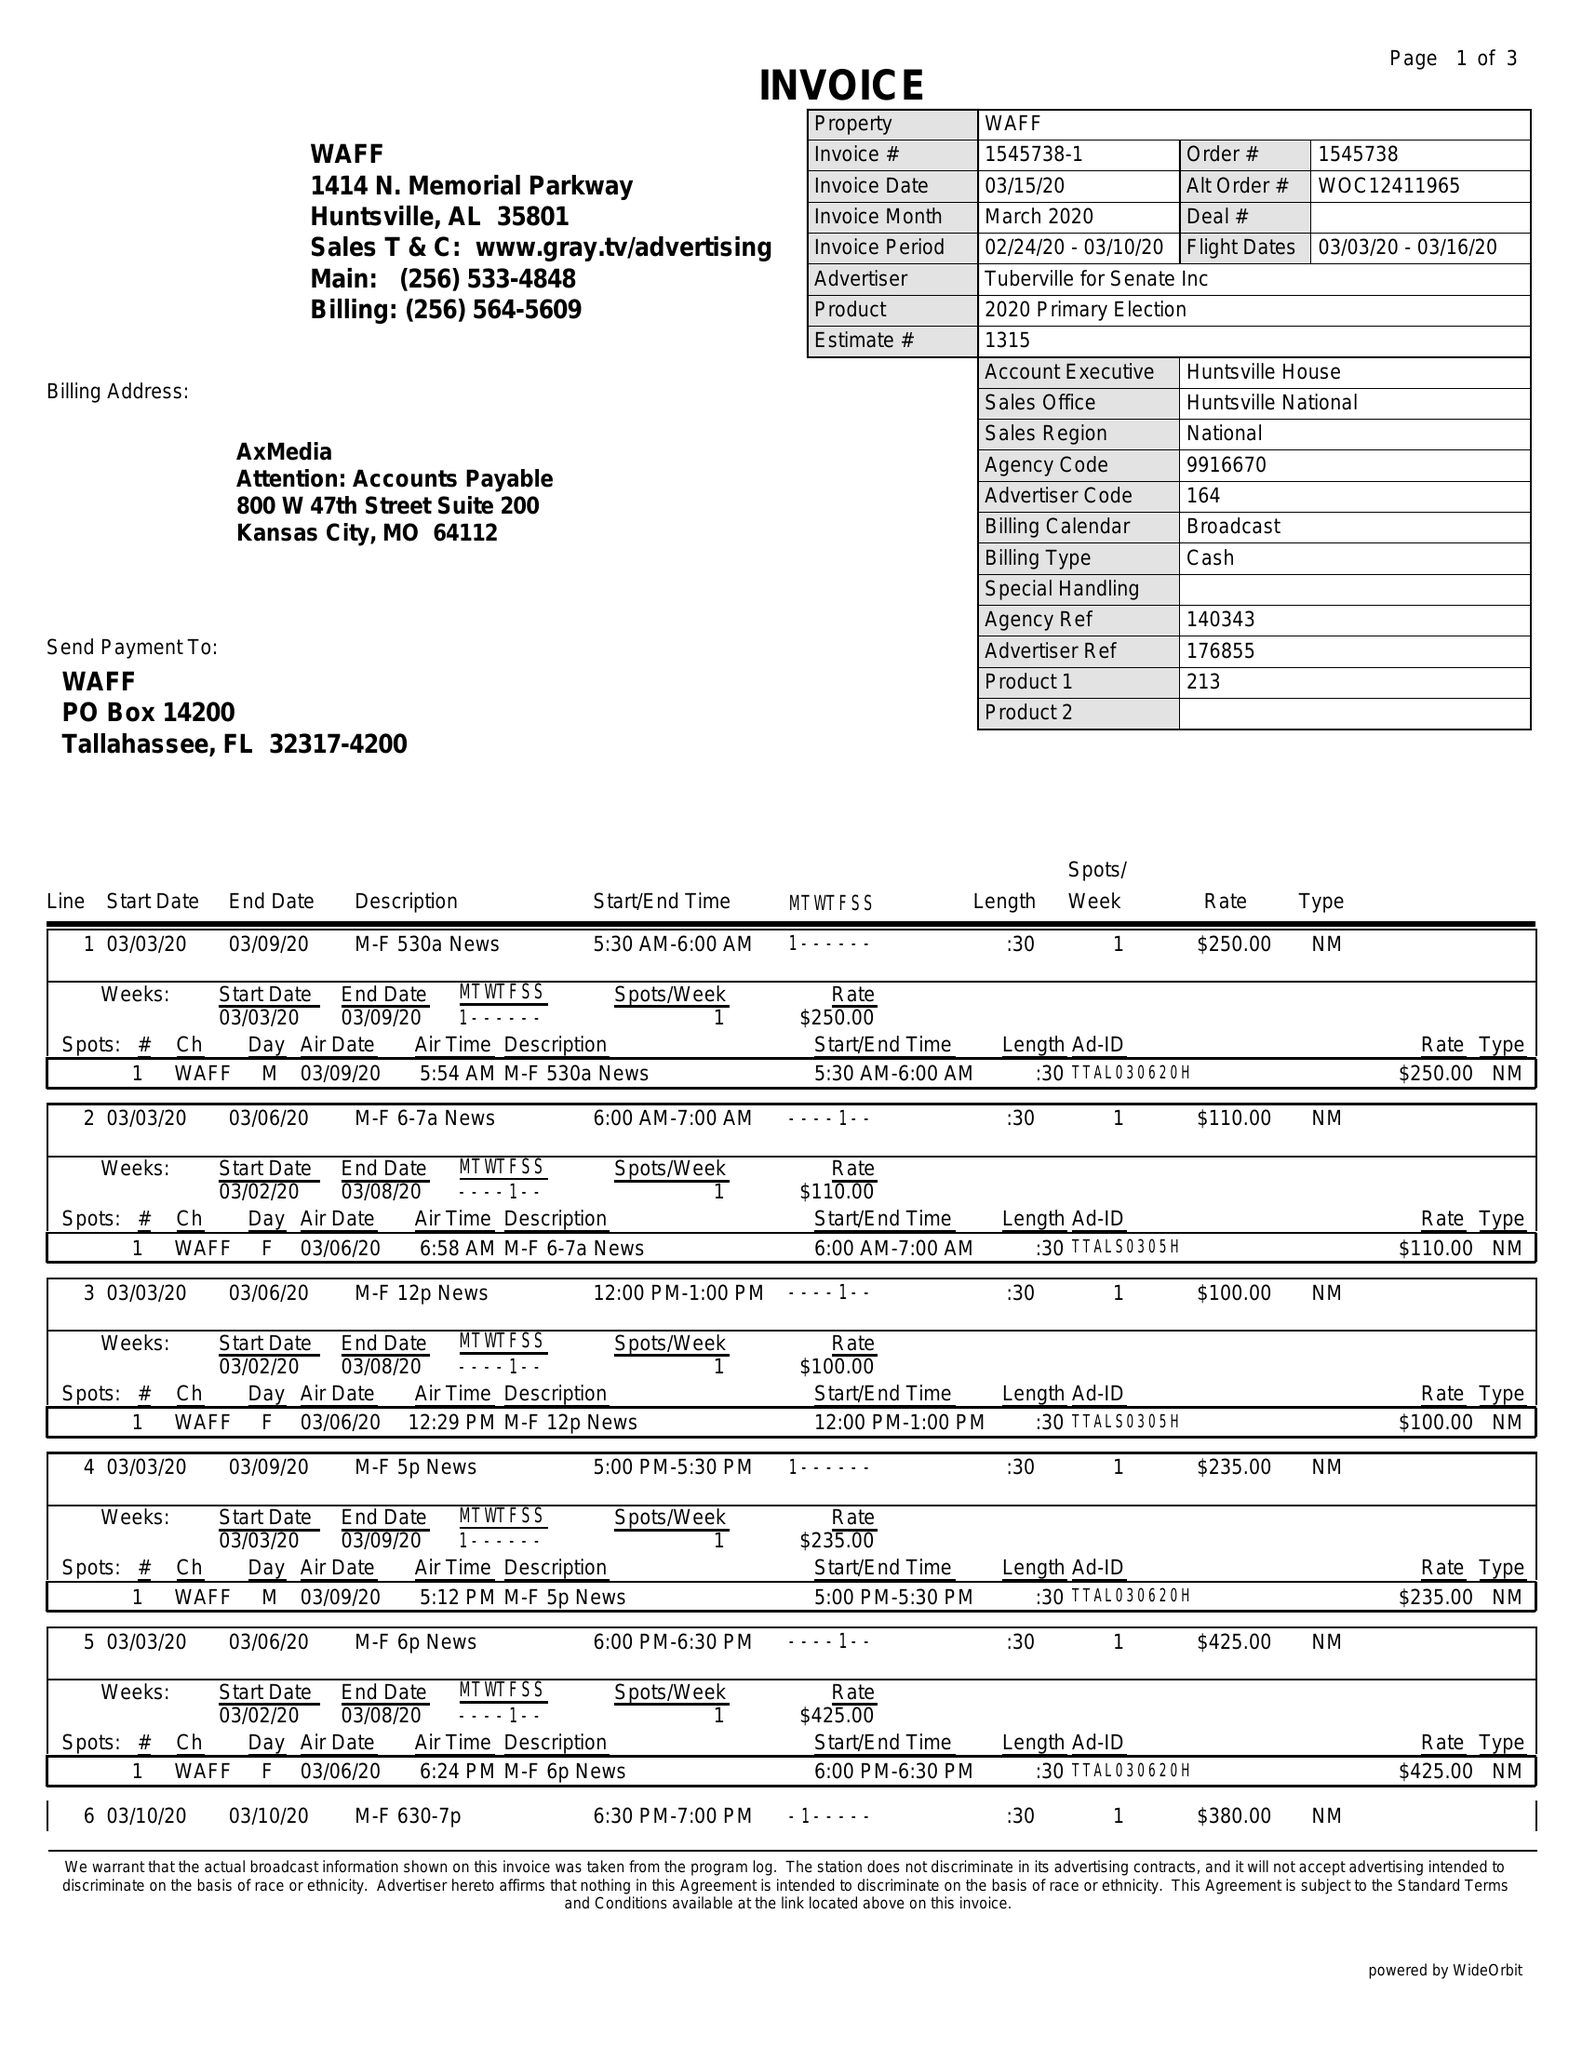What is the value for the contract_num?
Answer the question using a single word or phrase. 1545738 